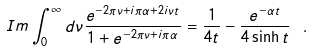Convert formula to latex. <formula><loc_0><loc_0><loc_500><loc_500>I m \int _ { 0 } ^ { \infty } d \nu \frac { e ^ { - 2 \pi \nu + i \pi \alpha + 2 i \nu t } } { 1 + e ^ { - 2 \pi \nu + i \pi \alpha } } = \frac { 1 } { 4 t } - \frac { e ^ { - \alpha t } } { 4 \sinh t } \ .</formula> 